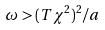<formula> <loc_0><loc_0><loc_500><loc_500>\omega > ( T \chi ^ { 2 } ) ^ { 2 } / a</formula> 